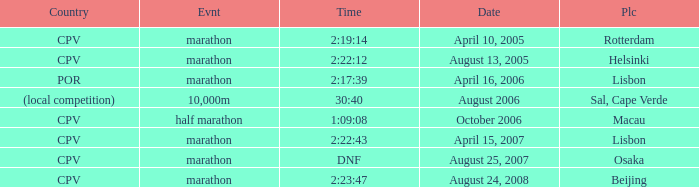What is the Place of the half marathon Event? Macau. 